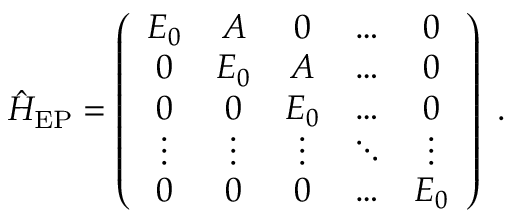Convert formula to latex. <formula><loc_0><loc_0><loc_500><loc_500>\hat { H } _ { E P } = \left ( \begin{array} { c c c c c } { E _ { 0 } } & { A } & { 0 } & { \dots } & { 0 } \\ { 0 } & { E _ { 0 } } & { A } & { \dots } & { 0 } \\ { 0 } & { 0 } & { E _ { 0 } } & { \dots } & { 0 } \\ { \vdots } & { \vdots } & { \vdots } & { \ddots } & { \vdots } \\ { 0 } & { 0 } & { 0 } & { \dots } & { E _ { 0 } } \end{array} \right ) \ .</formula> 